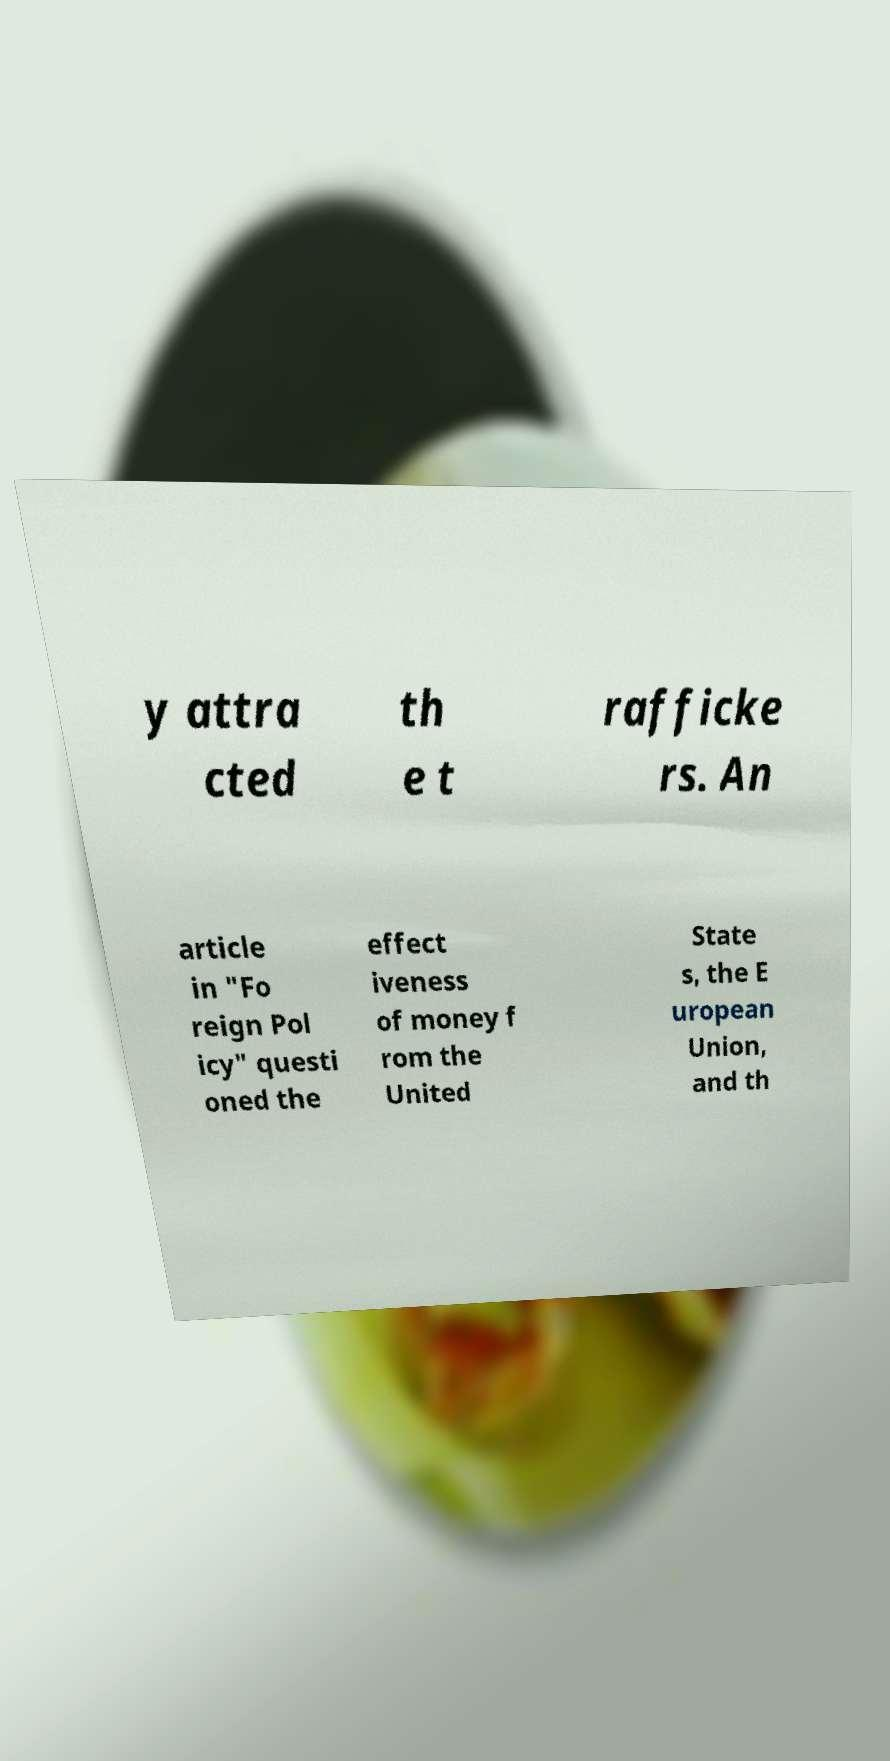Can you read and provide the text displayed in the image?This photo seems to have some interesting text. Can you extract and type it out for me? y attra cted th e t rafficke rs. An article in "Fo reign Pol icy" questi oned the effect iveness of money f rom the United State s, the E uropean Union, and th 